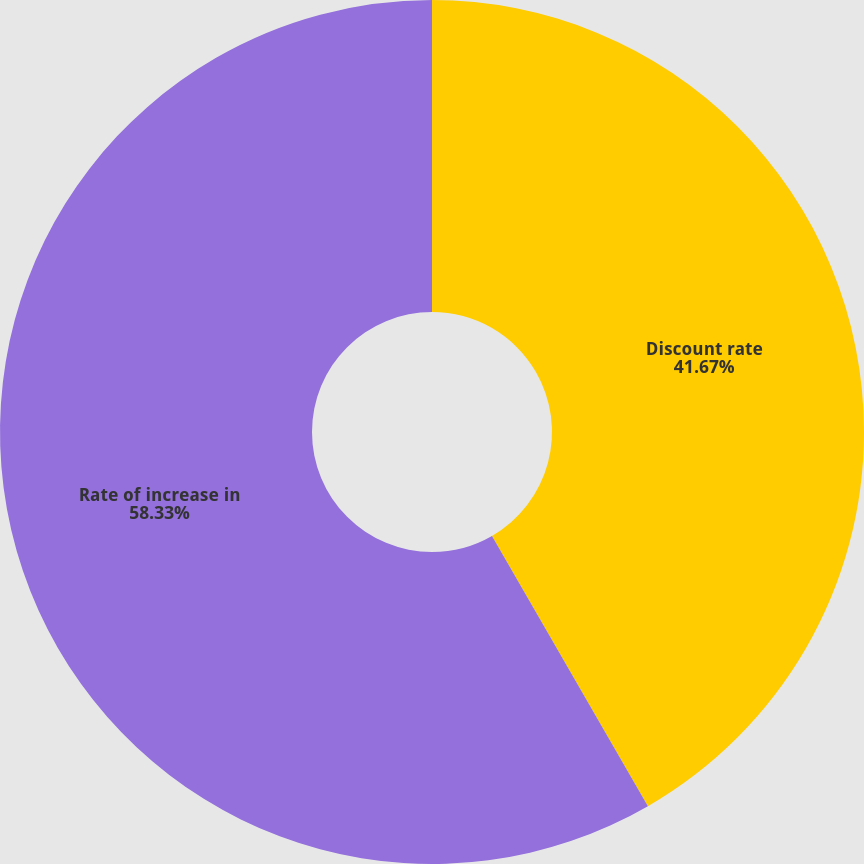Convert chart. <chart><loc_0><loc_0><loc_500><loc_500><pie_chart><fcel>Discount rate<fcel>Rate of increase in<nl><fcel>41.67%<fcel>58.33%<nl></chart> 